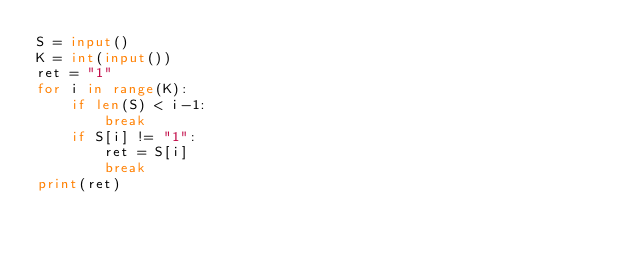Convert code to text. <code><loc_0><loc_0><loc_500><loc_500><_Python_>S = input()
K = int(input())
ret = "1"
for i in range(K):
    if len(S) < i-1:
        break
    if S[i] != "1":
        ret = S[i]
        break
print(ret)
</code> 